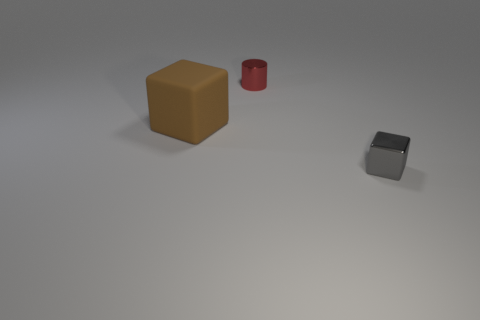How many other red metal cylinders have the same size as the red cylinder?
Keep it short and to the point. 0. Is there a thing that is to the right of the small thing that is left of the tiny metallic block?
Your response must be concise. Yes. How many things are either tiny cubes or small red cylinders?
Ensure brevity in your answer.  2. What color is the small metallic object in front of the block to the left of the small object in front of the big brown matte cube?
Your answer should be compact. Gray. Is the metallic cube the same size as the red metallic object?
Provide a succinct answer. Yes. What number of things are either tiny metallic objects in front of the metal cylinder or objects behind the gray thing?
Ensure brevity in your answer.  3. What is the tiny thing behind the thing that is right of the red shiny object made of?
Provide a succinct answer. Metal. How many other things are made of the same material as the large brown cube?
Offer a very short reply. 0. Do the gray metal thing and the big brown object have the same shape?
Make the answer very short. Yes. There is a thing to the left of the tiny red cylinder; what size is it?
Keep it short and to the point. Large. 